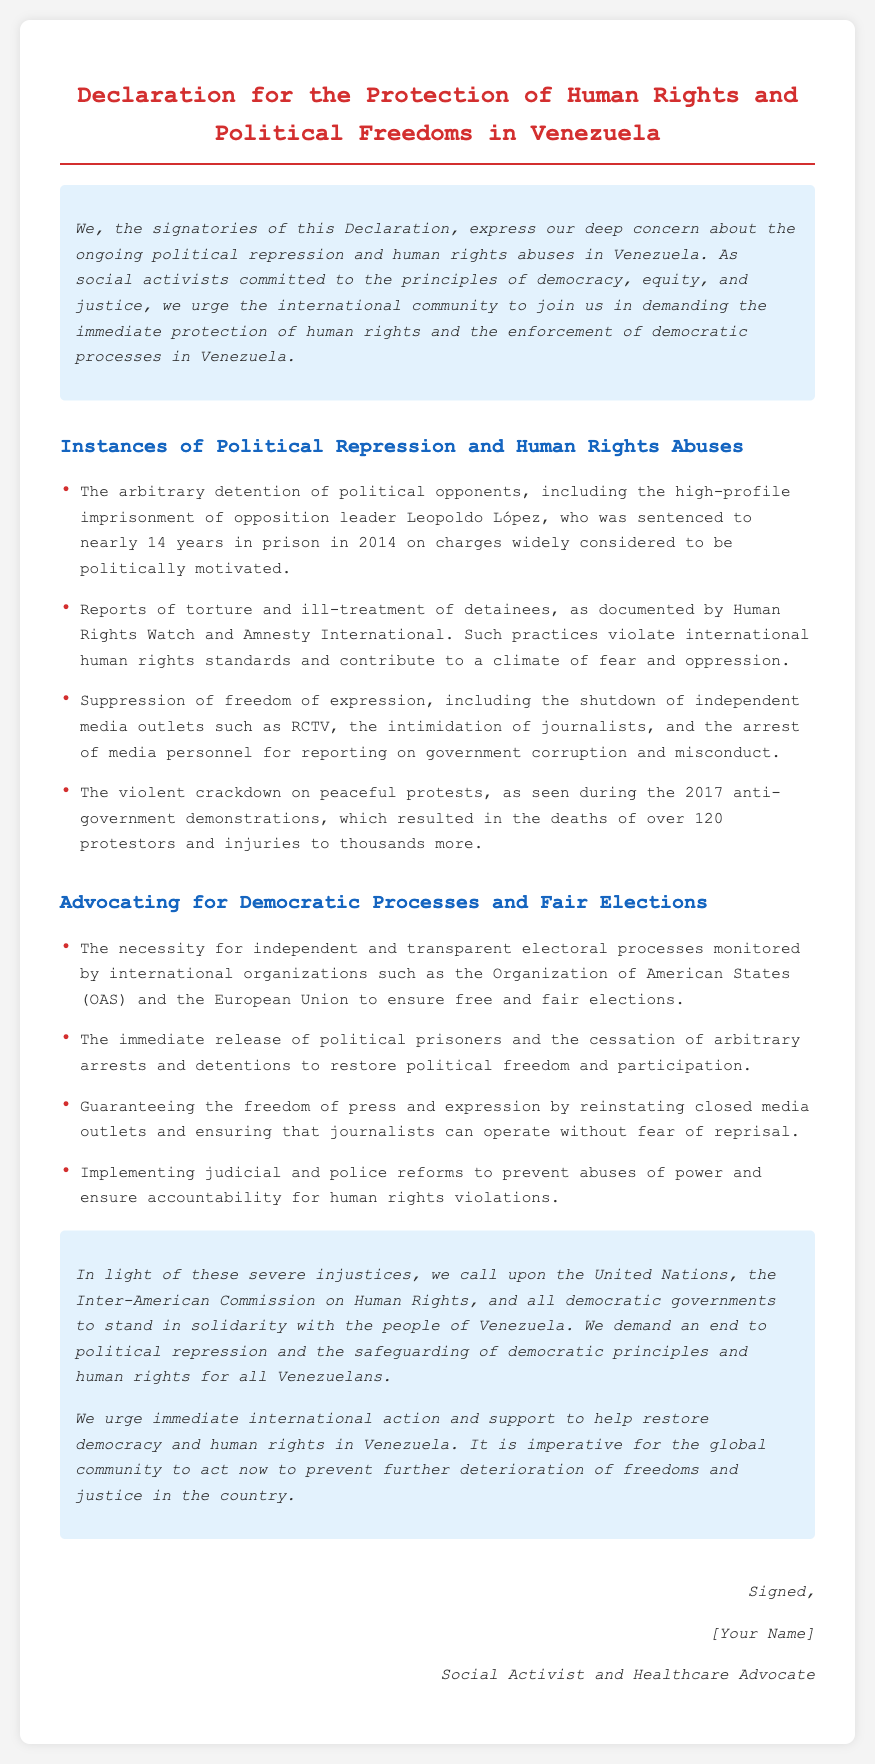What is the title of the document? The title of the document is explicitly stated at the top of the rendered HTML content.
Answer: Declaration for the Protection of Human Rights and Political Freedoms in Venezuela Who is mentioned as a high-profile political prisoner? The document specifically names a high-profile political prisoner in relation to political repression in Venezuela.
Answer: Leopoldo López How many protestors were reported dead during the 2017 demonstrations? The document provides a specific number related to the casualties during the protests.
Answer: over 120 What international organizations are mentioned for monitoring elections? The document lists organizations that should oversee independent and transparent electoral processes.
Answer: Organization of American States (OAS) and the European Union What is the call to action directed at the United Nations? The conclusion of the document specifies a particular request directed at the United Nations regarding political repression.
Answer: Stand in solidarity with the people of Venezuela What type of reforms does the document advocate for to prevent abuses? The document outlines specific reforms needed within the judicial and police sectors to enhance accountability.
Answer: Judicial and police reforms 